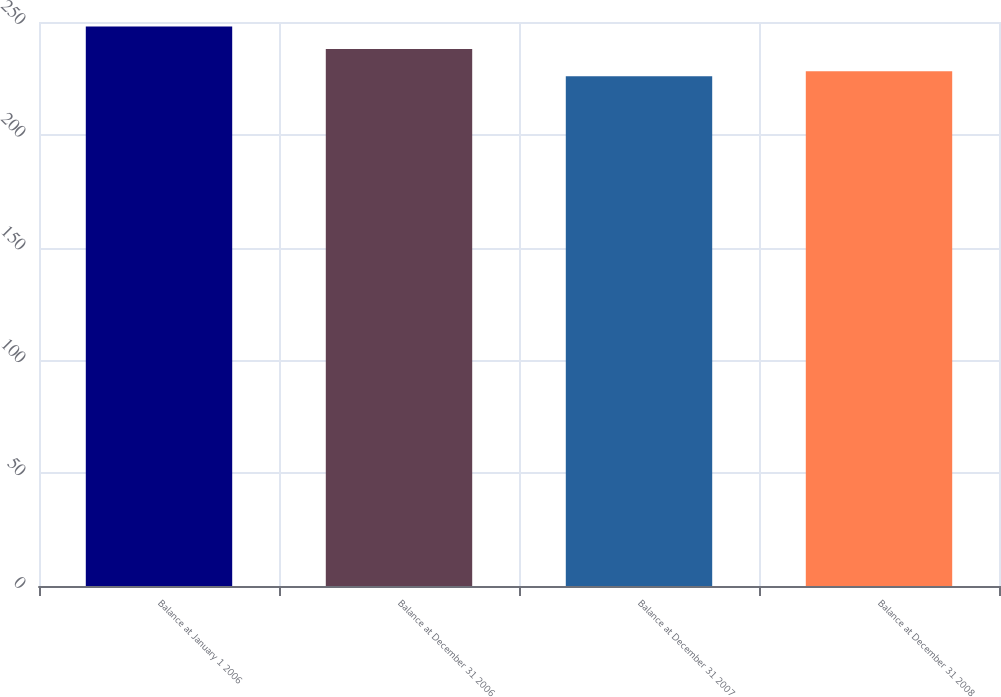<chart> <loc_0><loc_0><loc_500><loc_500><bar_chart><fcel>Balance at January 1 2006<fcel>Balance at December 31 2006<fcel>Balance at December 31 2007<fcel>Balance at December 31 2008<nl><fcel>248<fcel>238<fcel>226<fcel>228.2<nl></chart> 